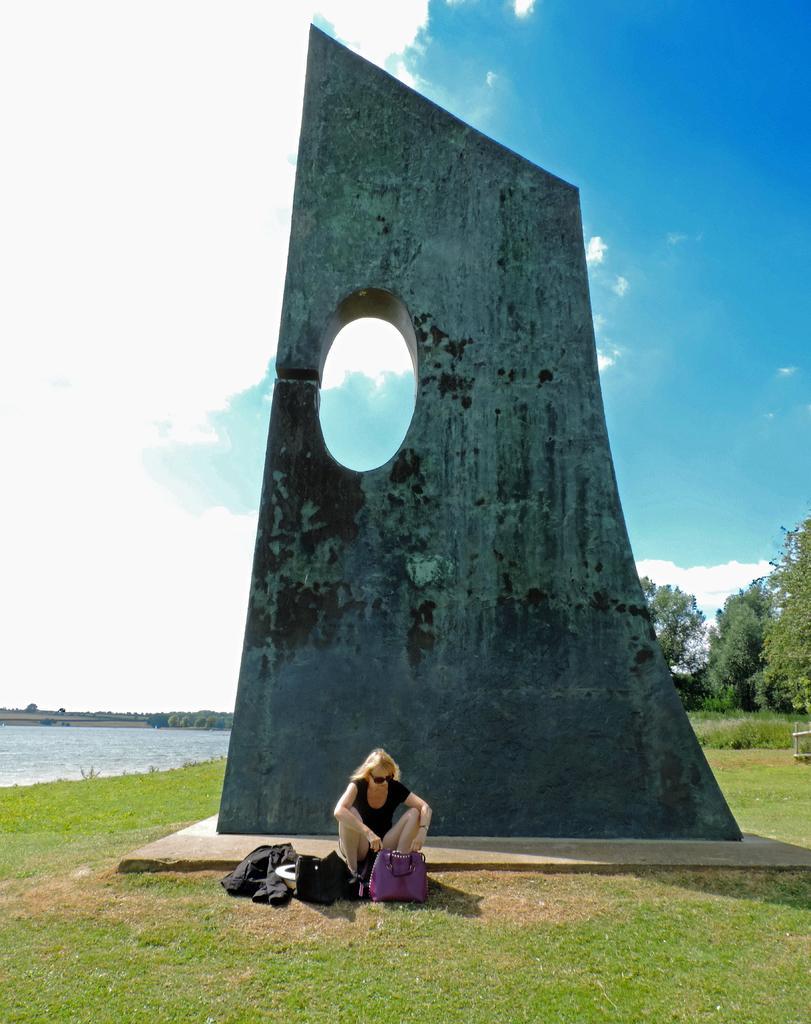How would you summarize this image in a sentence or two? In this image there is a wall structure, in front of that there is a lady sitting and there are few bags and a jacket on the surface of the grass. On the left side of the image there is a river. In the background there are trees and the sky. 